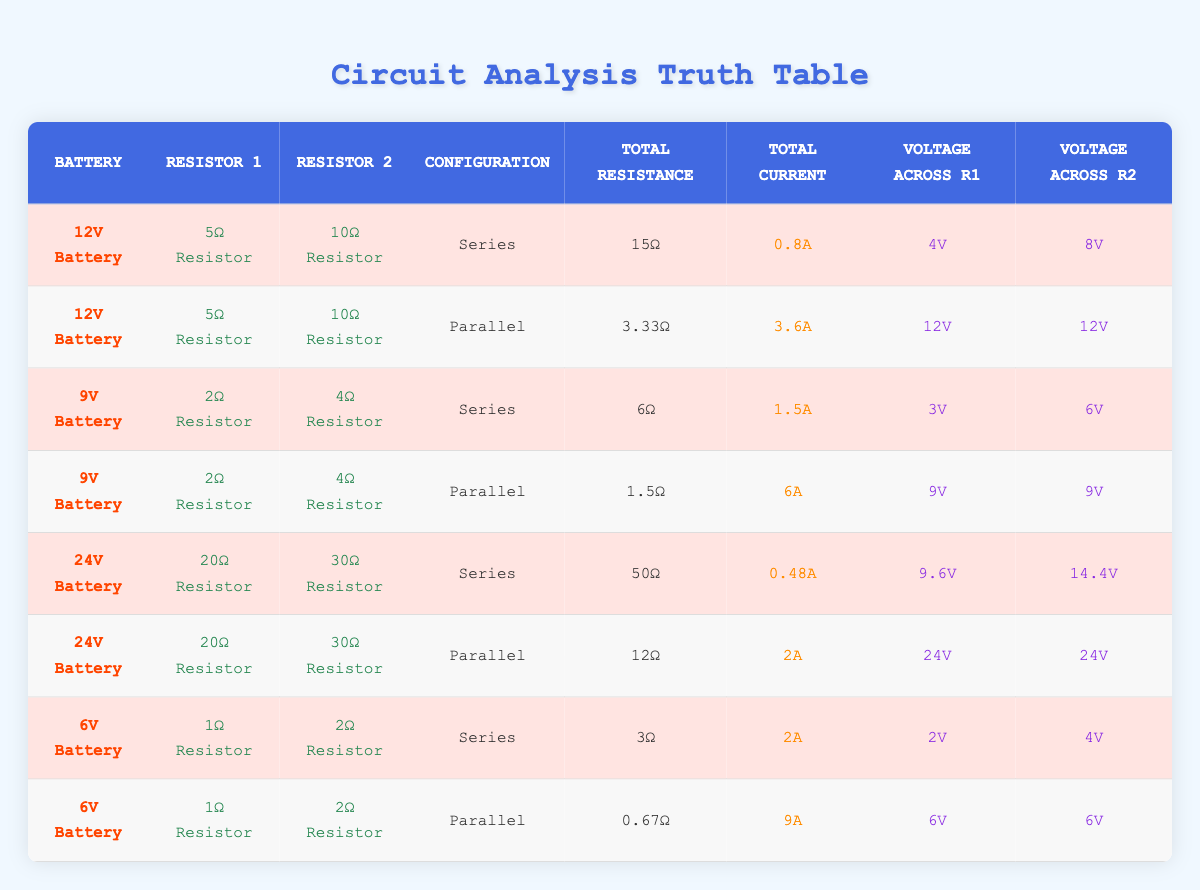What is the total current when two resistors of 5Ω and 10Ω are connected in series with a 12V battery? In the table, for the 12V battery connected in series, the total current is listed as 0.8A.
Answer: 0.8A What is the total resistance in the parallel configuration of the resistors with a 6V battery? The table shows that for the parallel configuration of the resistors with a 6V battery, the total resistance is 0.67Ω.
Answer: 0.67Ω Does a 12V battery connected in parallel with two resistors deliver the same voltage across each resistor? Yes, according to the table, both resistors in the parallel configuration with the 12V battery have a voltage of 12V across them.
Answer: Yes What is the difference in the total current between the series and parallel configurations for the 6V battery? From the table, in the series configuration with a 6V battery, the total current is 2A, and in the parallel configuration, it is 9A. The difference is 9A - 2A = 7A.
Answer: 7A What is the average voltage across the resistors when two resistors of 2Ω and 4Ω are connected in series with a 9V battery? The table shows that the voltage across the 2Ω resistor is 3V and across the 4Ω resistor is 6V. Adding these gives 3V + 6V = 9V. The average voltage is 9V / 2 = 4.5V.
Answer: 4.5V What configuration has a lower total resistance, series or parallel, when using the 24V battery? From the table, the series configuration has a total resistance of 50Ω, while the parallel configuration has a total resistance of 12Ω. Since 12Ω < 50Ω, the parallel configuration has a lower total resistance.
Answer: Parallel If we combine the total currents from both configurations using the 12V battery, what is the resulting total current? The total current in series is 0.8A and in parallel is 3.6A. Adding these gives 0.8A + 3.6A = 4.4A.
Answer: 4.4A Is the voltage across the 20Ω resistor the same as the voltage across the 30Ω resistor in the series configuration with the 24V battery? The table indicates that in the series configuration with a 24V battery, the voltage across the 20Ω resistor is 9.6V, while the voltage across the 30Ω resistor is 14.4V. Since 9.6V is not equal to 14.4V, they are not the same.
Answer: No What is the total current flowing in the circuit with a 9V battery, 2Ω resistor, and 4Ω resistor when configured in parallel? According to the table, when the 9V battery is connected in parallel with the 2Ω and 4Ω resistors, the total current is given as 6A.
Answer: 6A 